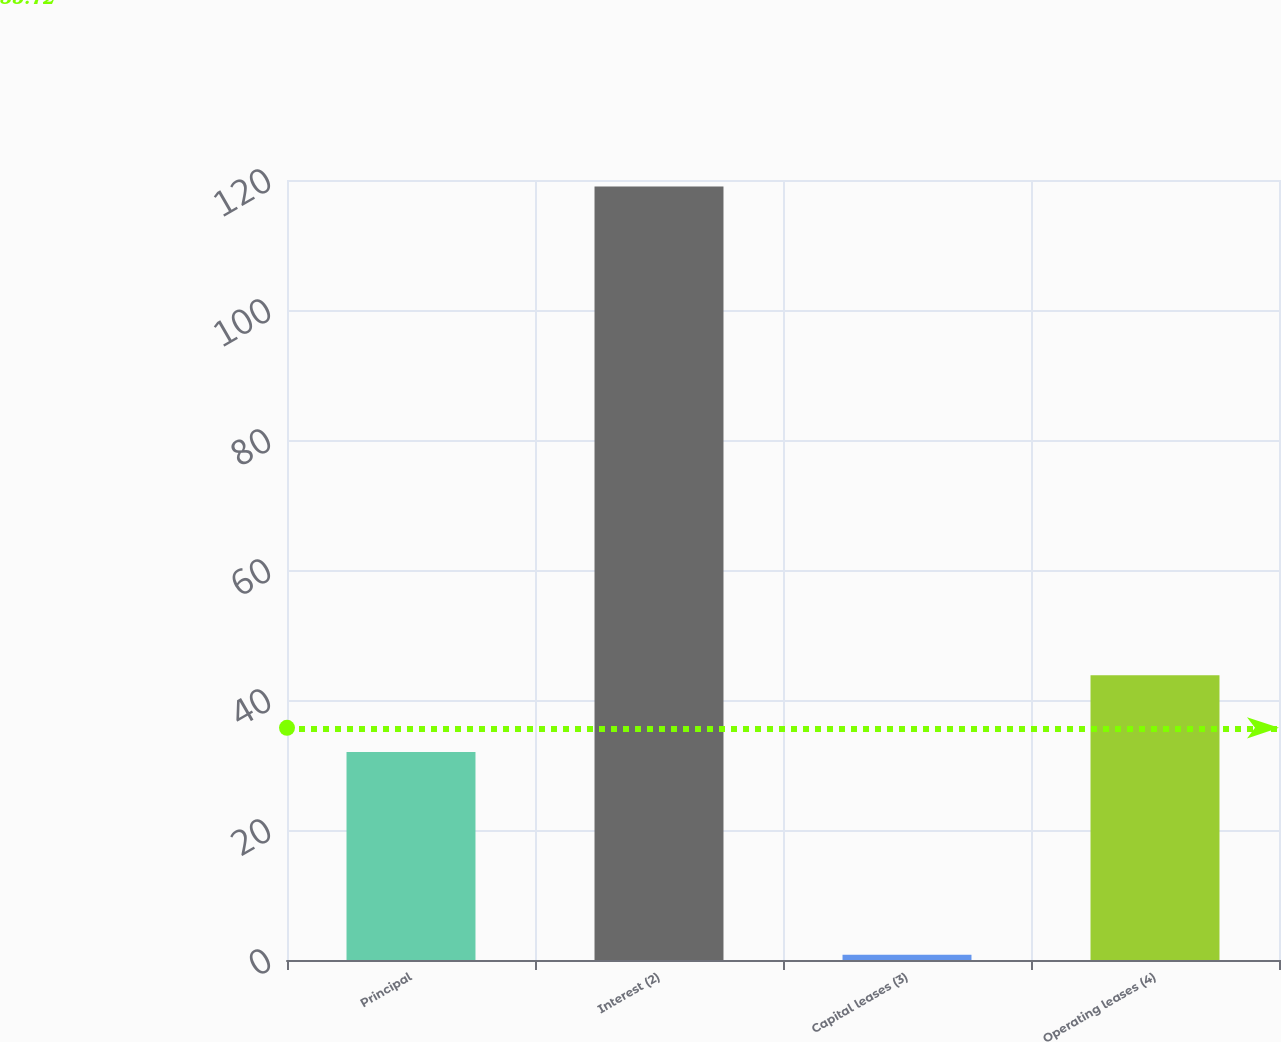<chart> <loc_0><loc_0><loc_500><loc_500><bar_chart><fcel>Principal<fcel>Interest (2)<fcel>Capital leases (3)<fcel>Operating leases (4)<nl><fcel>32<fcel>119<fcel>0.8<fcel>43.82<nl></chart> 